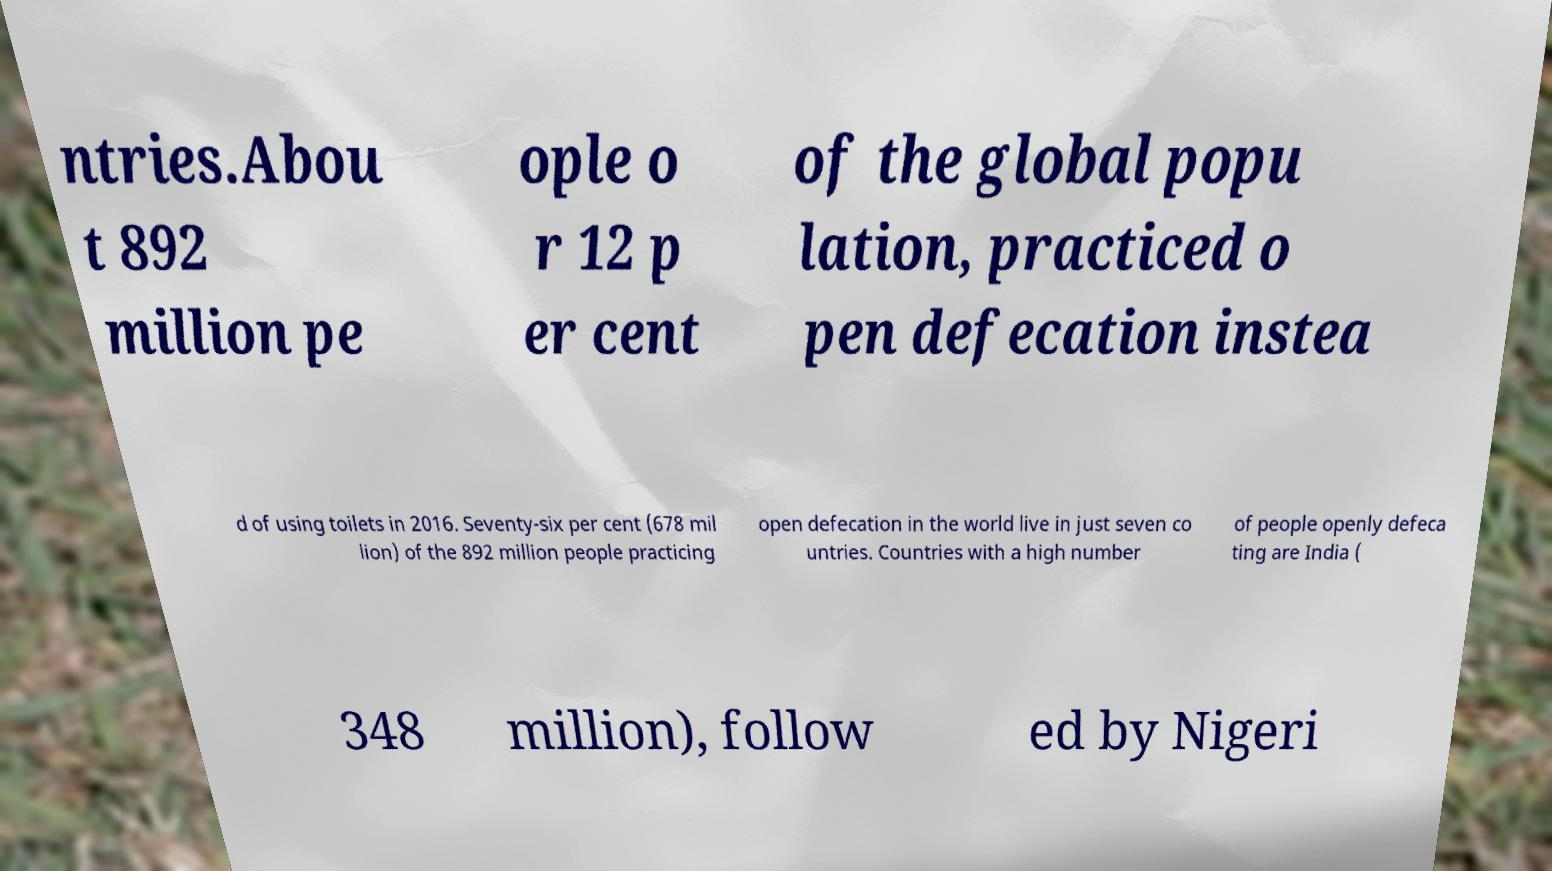I need the written content from this picture converted into text. Can you do that? ntries.Abou t 892 million pe ople o r 12 p er cent of the global popu lation, practiced o pen defecation instea d of using toilets in 2016. Seventy-six per cent (678 mil lion) of the 892 million people practicing open defecation in the world live in just seven co untries. Countries with a high number of people openly defeca ting are India ( 348 million), follow ed by Nigeri 